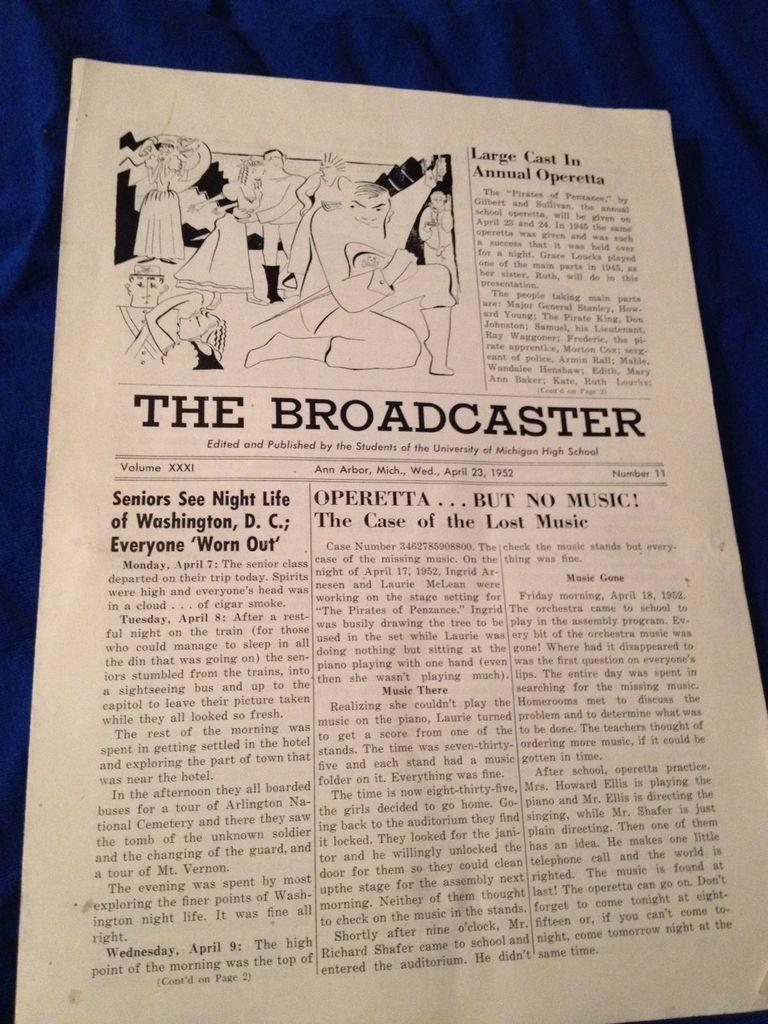<image>
Relay a brief, clear account of the picture shown. A page from the Michigan High School newspaper "The Broadcaster", dated April 23, 1952 with an article titled "Large Cast in Annual Operetta". 